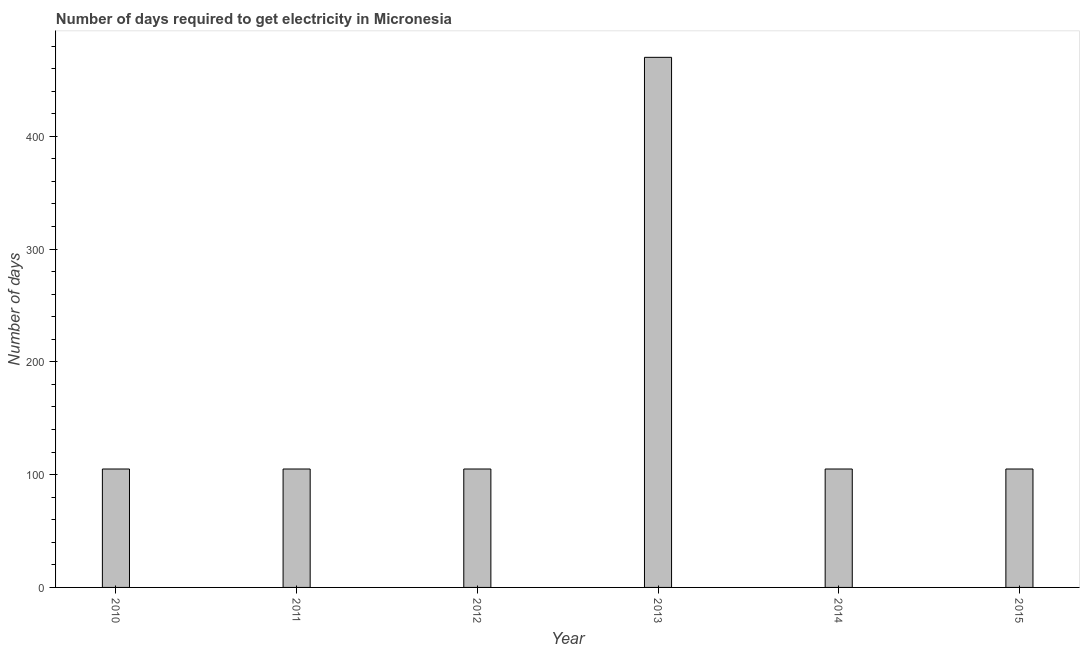Does the graph contain any zero values?
Ensure brevity in your answer.  No. What is the title of the graph?
Provide a succinct answer. Number of days required to get electricity in Micronesia. What is the label or title of the X-axis?
Make the answer very short. Year. What is the label or title of the Y-axis?
Your answer should be very brief. Number of days. What is the time to get electricity in 2014?
Make the answer very short. 105. Across all years, what is the maximum time to get electricity?
Give a very brief answer. 470. Across all years, what is the minimum time to get electricity?
Give a very brief answer. 105. In which year was the time to get electricity maximum?
Your response must be concise. 2013. In which year was the time to get electricity minimum?
Keep it short and to the point. 2010. What is the sum of the time to get electricity?
Your answer should be compact. 995. What is the difference between the time to get electricity in 2010 and 2014?
Keep it short and to the point. 0. What is the average time to get electricity per year?
Give a very brief answer. 165. What is the median time to get electricity?
Ensure brevity in your answer.  105. In how many years, is the time to get electricity greater than 380 ?
Offer a terse response. 1. What is the ratio of the time to get electricity in 2010 to that in 2015?
Give a very brief answer. 1. Is the time to get electricity in 2010 less than that in 2012?
Give a very brief answer. No. Is the difference between the time to get electricity in 2014 and 2015 greater than the difference between any two years?
Your answer should be compact. No. What is the difference between the highest and the second highest time to get electricity?
Make the answer very short. 365. What is the difference between the highest and the lowest time to get electricity?
Your answer should be very brief. 365. How many bars are there?
Ensure brevity in your answer.  6. How many years are there in the graph?
Ensure brevity in your answer.  6. What is the Number of days in 2010?
Make the answer very short. 105. What is the Number of days of 2011?
Your answer should be very brief. 105. What is the Number of days in 2012?
Provide a short and direct response. 105. What is the Number of days in 2013?
Your response must be concise. 470. What is the Number of days in 2014?
Offer a very short reply. 105. What is the Number of days in 2015?
Ensure brevity in your answer.  105. What is the difference between the Number of days in 2010 and 2013?
Your response must be concise. -365. What is the difference between the Number of days in 2010 and 2014?
Ensure brevity in your answer.  0. What is the difference between the Number of days in 2011 and 2013?
Give a very brief answer. -365. What is the difference between the Number of days in 2011 and 2015?
Your answer should be compact. 0. What is the difference between the Number of days in 2012 and 2013?
Keep it short and to the point. -365. What is the difference between the Number of days in 2013 and 2014?
Provide a short and direct response. 365. What is the difference between the Number of days in 2013 and 2015?
Ensure brevity in your answer.  365. What is the difference between the Number of days in 2014 and 2015?
Make the answer very short. 0. What is the ratio of the Number of days in 2010 to that in 2012?
Make the answer very short. 1. What is the ratio of the Number of days in 2010 to that in 2013?
Keep it short and to the point. 0.22. What is the ratio of the Number of days in 2011 to that in 2012?
Your answer should be compact. 1. What is the ratio of the Number of days in 2011 to that in 2013?
Your answer should be very brief. 0.22. What is the ratio of the Number of days in 2012 to that in 2013?
Keep it short and to the point. 0.22. What is the ratio of the Number of days in 2012 to that in 2014?
Provide a short and direct response. 1. What is the ratio of the Number of days in 2012 to that in 2015?
Give a very brief answer. 1. What is the ratio of the Number of days in 2013 to that in 2014?
Give a very brief answer. 4.48. What is the ratio of the Number of days in 2013 to that in 2015?
Your response must be concise. 4.48. What is the ratio of the Number of days in 2014 to that in 2015?
Provide a succinct answer. 1. 